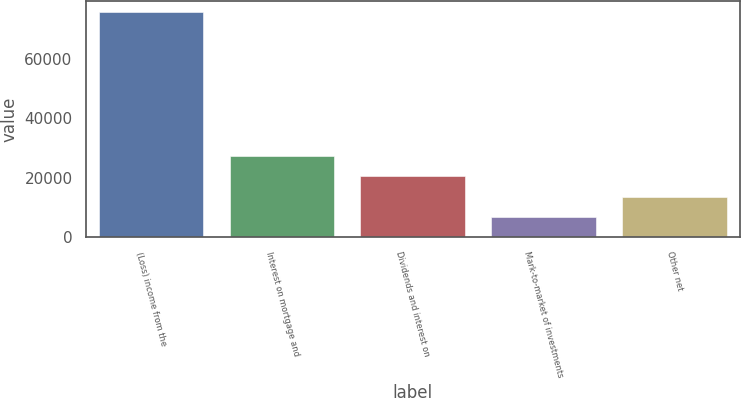Convert chart to OTSL. <chart><loc_0><loc_0><loc_500><loc_500><bar_chart><fcel>(Loss) income from the<fcel>Interest on mortgage and<fcel>Dividends and interest on<fcel>Mark-to-market of investments<fcel>Other net<nl><fcel>75815<fcel>27510.8<fcel>20610.2<fcel>6809<fcel>13709.6<nl></chart> 